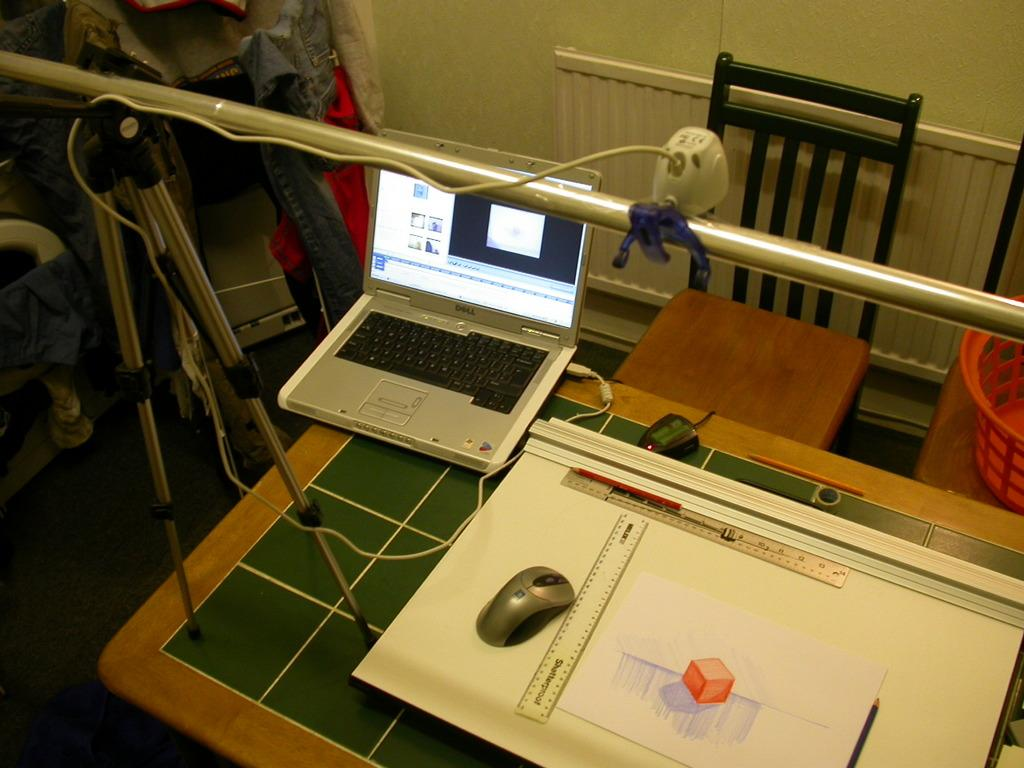What electronic device is on the table in the image? There is a laptop on the table in the image. What type of paper is on the table? There is a chart paper on the table. What tool is on the table for measuring weight? There is a scale on the table. What writing instrument is on the table? There is a pencil on the table. What piece of furniture is behind the table? There is a chair behind the table. What object is behind the table for holding items? There is a stand behind the table. Can you see a star shining brightly in the image? There is no star visible in the image; it features a table with various objects on it. Is there a bite taken out of the laptop in the image? No, there is no bite taken out of the laptop in the image. 